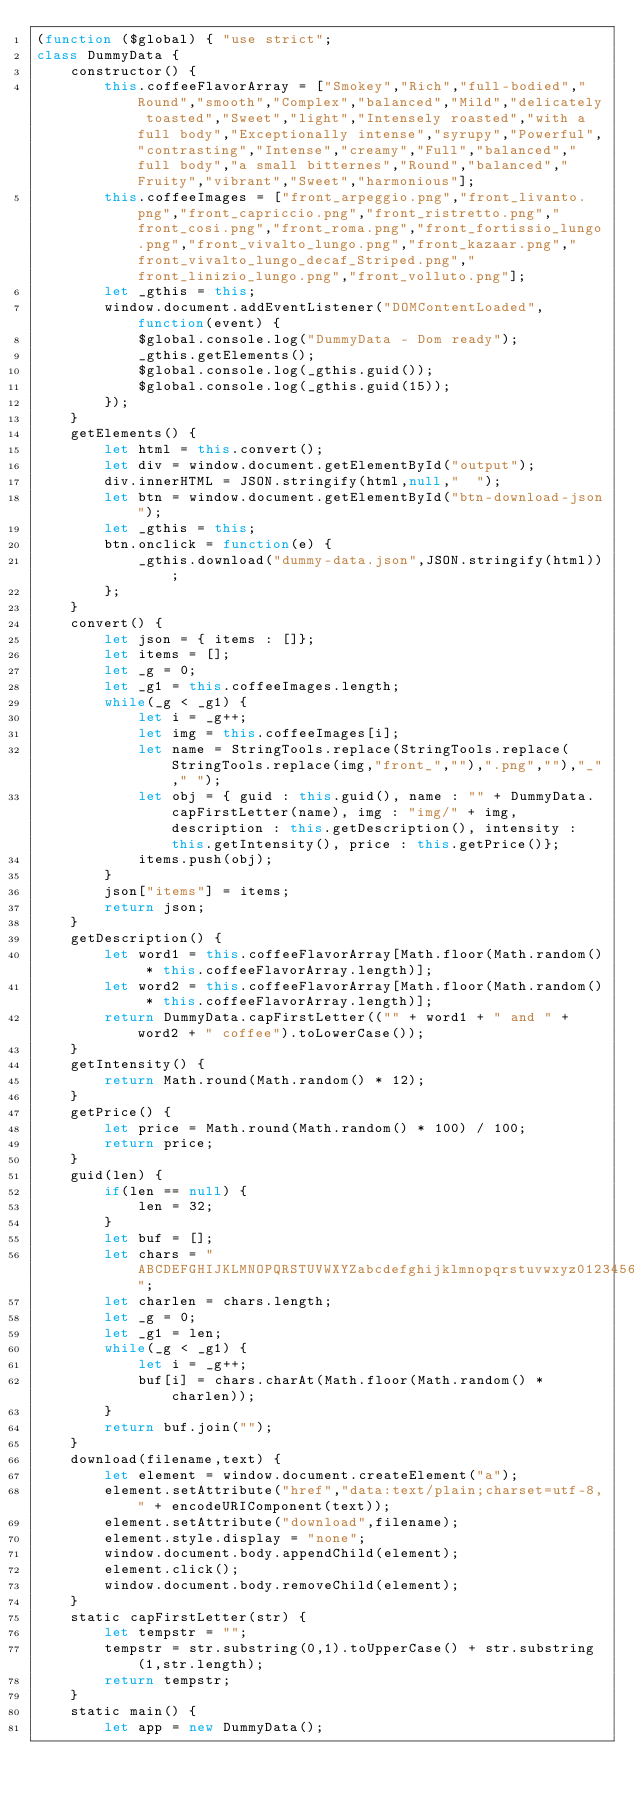<code> <loc_0><loc_0><loc_500><loc_500><_JavaScript_>(function ($global) { "use strict";
class DummyData {
	constructor() {
		this.coffeeFlavorArray = ["Smokey","Rich","full-bodied","Round","smooth","Complex","balanced","Mild","delicately toasted","Sweet","light","Intensely roasted","with a full body","Exceptionally intense","syrupy","Powerful","contrasting","Intense","creamy","Full","balanced","full body","a small bitternes","Round","balanced","Fruity","vibrant","Sweet","harmonious"];
		this.coffeeImages = ["front_arpeggio.png","front_livanto.png","front_capriccio.png","front_ristretto.png","front_cosi.png","front_roma.png","front_fortissio_lungo.png","front_vivalto_lungo.png","front_kazaar.png","front_vivalto_lungo_decaf_Striped.png","front_linizio_lungo.png","front_volluto.png"];
		let _gthis = this;
		window.document.addEventListener("DOMContentLoaded",function(event) {
			$global.console.log("DummyData - Dom ready");
			_gthis.getElements();
			$global.console.log(_gthis.guid());
			$global.console.log(_gthis.guid(15));
		});
	}
	getElements() {
		let html = this.convert();
		let div = window.document.getElementById("output");
		div.innerHTML = JSON.stringify(html,null,"  ");
		let btn = window.document.getElementById("btn-download-json");
		let _gthis = this;
		btn.onclick = function(e) {
			_gthis.download("dummy-data.json",JSON.stringify(html));
		};
	}
	convert() {
		let json = { items : []};
		let items = [];
		let _g = 0;
		let _g1 = this.coffeeImages.length;
		while(_g < _g1) {
			let i = _g++;
			let img = this.coffeeImages[i];
			let name = StringTools.replace(StringTools.replace(StringTools.replace(img,"front_",""),".png",""),"_"," ");
			let obj = { guid : this.guid(), name : "" + DummyData.capFirstLetter(name), img : "img/" + img, description : this.getDescription(), intensity : this.getIntensity(), price : this.getPrice()};
			items.push(obj);
		}
		json["items"] = items;
		return json;
	}
	getDescription() {
		let word1 = this.coffeeFlavorArray[Math.floor(Math.random() * this.coffeeFlavorArray.length)];
		let word2 = this.coffeeFlavorArray[Math.floor(Math.random() * this.coffeeFlavorArray.length)];
		return DummyData.capFirstLetter(("" + word1 + " and " + word2 + " coffee").toLowerCase());
	}
	getIntensity() {
		return Math.round(Math.random() * 12);
	}
	getPrice() {
		let price = Math.round(Math.random() * 100) / 100;
		return price;
	}
	guid(len) {
		if(len == null) {
			len = 32;
		}
		let buf = [];
		let chars = "ABCDEFGHIJKLMNOPQRSTUVWXYZabcdefghijklmnopqrstuvwxyz0123456789";
		let charlen = chars.length;
		let _g = 0;
		let _g1 = len;
		while(_g < _g1) {
			let i = _g++;
			buf[i] = chars.charAt(Math.floor(Math.random() * charlen));
		}
		return buf.join("");
	}
	download(filename,text) {
		let element = window.document.createElement("a");
		element.setAttribute("href","data:text/plain;charset=utf-8," + encodeURIComponent(text));
		element.setAttribute("download",filename);
		element.style.display = "none";
		window.document.body.appendChild(element);
		element.click();
		window.document.body.removeChild(element);
	}
	static capFirstLetter(str) {
		let tempstr = "";
		tempstr = str.substring(0,1).toUpperCase() + str.substring(1,str.length);
		return tempstr;
	}
	static main() {
		let app = new DummyData();</code> 